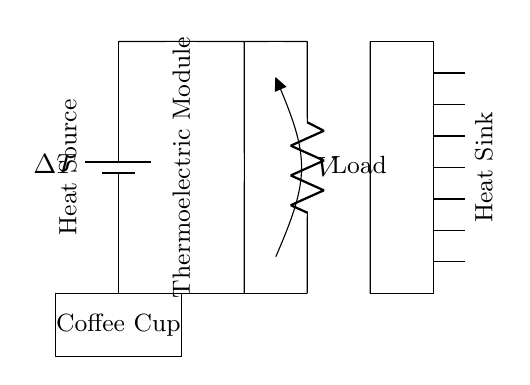What is the heat source in this circuit? The heat source is indicated as a "Heat Source" label in the circuit diagram and is associated with the coffee cup, which serves as an external heat source for the thermoelectric module.
Answer: Heat Source What component generates electricity from the temperature difference? The circuit has a "Thermoelectric Module" labeled in the diagram, which converts heat energy from the coffee cup into electrical energy through the Seebeck effect.
Answer: Thermoelectric Module What does the voltmeter measure in this circuit? The voltmeter is connected across the circuit and is labeled as "V," meaning it measures the voltage produced by the thermoelectric module and the load. This shows the electrical potential generated.
Answer: Voltage How are the load and the thermoelectric module connected? The load is connected in series with the thermoelectric module, as indicated by the lines in the circuit. The current flows from the module to the load in a single path, forming a series circuit.
Answer: Series connection What is the role of the heat sink in the circuit? The "Heat Sink" is used to keep one side of the thermoelectric module cool, thus maintaining a temperature gradient across the module. This temperature difference is essential for generating electricity.
Answer: Maintain temperature gradient 